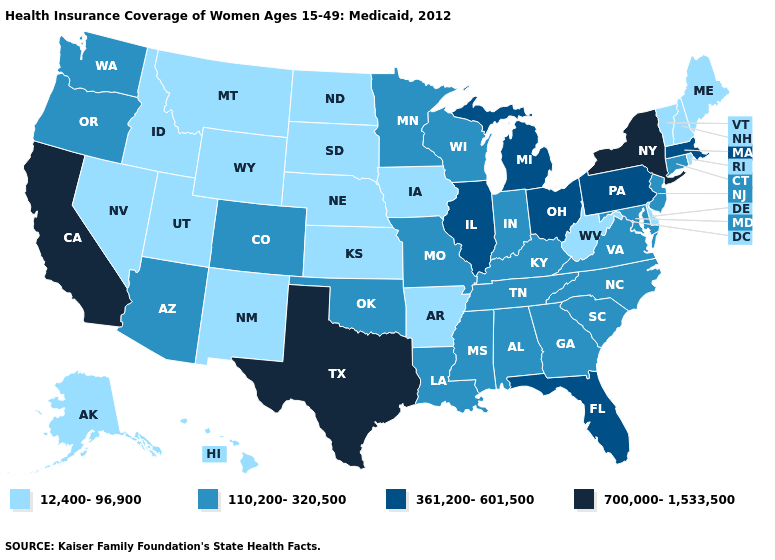What is the highest value in states that border South Carolina?
Quick response, please. 110,200-320,500. What is the highest value in states that border Georgia?
Short answer required. 361,200-601,500. Does Vermont have the lowest value in the Northeast?
Answer briefly. Yes. Does New Hampshire have a lower value than Iowa?
Short answer required. No. What is the highest value in the USA?
Quick response, please. 700,000-1,533,500. What is the value of Ohio?
Short answer required. 361,200-601,500. Does Rhode Island have a lower value than Michigan?
Quick response, please. Yes. Name the states that have a value in the range 110,200-320,500?
Quick response, please. Alabama, Arizona, Colorado, Connecticut, Georgia, Indiana, Kentucky, Louisiana, Maryland, Minnesota, Mississippi, Missouri, New Jersey, North Carolina, Oklahoma, Oregon, South Carolina, Tennessee, Virginia, Washington, Wisconsin. What is the value of Massachusetts?
Keep it brief. 361,200-601,500. What is the value of Nebraska?
Concise answer only. 12,400-96,900. Which states have the highest value in the USA?
Quick response, please. California, New York, Texas. Name the states that have a value in the range 110,200-320,500?
Concise answer only. Alabama, Arizona, Colorado, Connecticut, Georgia, Indiana, Kentucky, Louisiana, Maryland, Minnesota, Mississippi, Missouri, New Jersey, North Carolina, Oklahoma, Oregon, South Carolina, Tennessee, Virginia, Washington, Wisconsin. What is the value of Colorado?
Give a very brief answer. 110,200-320,500. Does the map have missing data?
Be succinct. No. What is the highest value in the USA?
Be succinct. 700,000-1,533,500. 